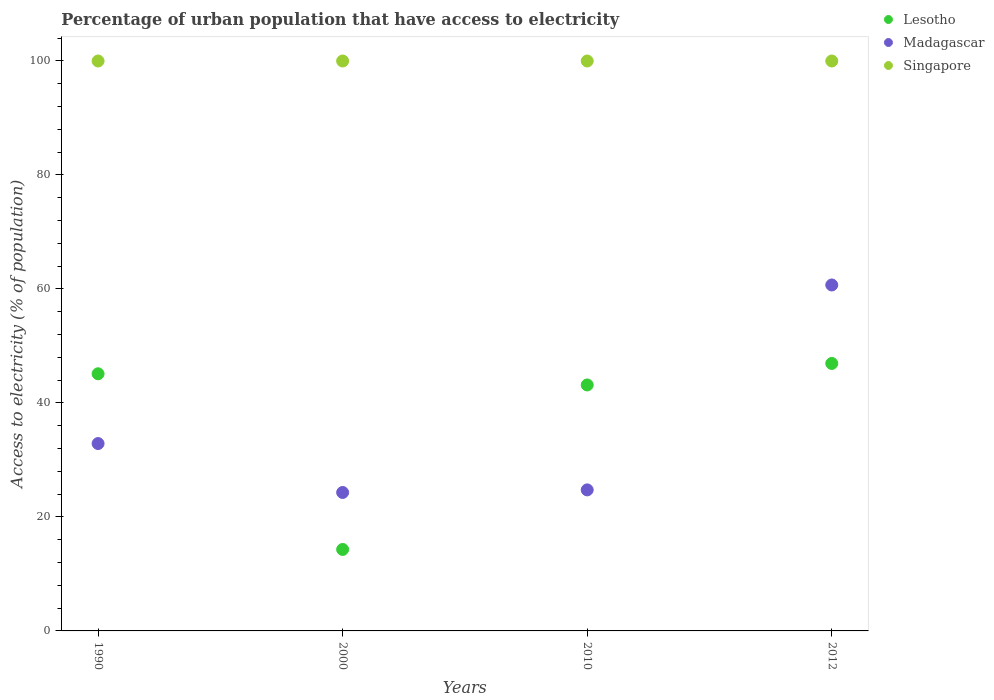How many different coloured dotlines are there?
Your response must be concise. 3. What is the percentage of urban population that have access to electricity in Lesotho in 1990?
Offer a terse response. 45.12. Across all years, what is the maximum percentage of urban population that have access to electricity in Lesotho?
Your answer should be compact. 46.93. Across all years, what is the minimum percentage of urban population that have access to electricity in Singapore?
Ensure brevity in your answer.  100. In which year was the percentage of urban population that have access to electricity in Madagascar maximum?
Give a very brief answer. 2012. In which year was the percentage of urban population that have access to electricity in Lesotho minimum?
Your response must be concise. 2000. What is the total percentage of urban population that have access to electricity in Singapore in the graph?
Provide a short and direct response. 400. What is the difference between the percentage of urban population that have access to electricity in Madagascar in 1990 and that in 2000?
Provide a short and direct response. 8.59. What is the difference between the percentage of urban population that have access to electricity in Singapore in 2010 and the percentage of urban population that have access to electricity in Madagascar in 2012?
Your answer should be compact. 39.3. What is the average percentage of urban population that have access to electricity in Lesotho per year?
Offer a very short reply. 37.38. In the year 2010, what is the difference between the percentage of urban population that have access to electricity in Singapore and percentage of urban population that have access to electricity in Madagascar?
Provide a succinct answer. 75.25. In how many years, is the percentage of urban population that have access to electricity in Lesotho greater than 52 %?
Give a very brief answer. 0. Is the percentage of urban population that have access to electricity in Lesotho in 2000 less than that in 2012?
Your answer should be compact. Yes. Is the difference between the percentage of urban population that have access to electricity in Singapore in 1990 and 2000 greater than the difference between the percentage of urban population that have access to electricity in Madagascar in 1990 and 2000?
Provide a succinct answer. No. What is the difference between the highest and the second highest percentage of urban population that have access to electricity in Lesotho?
Ensure brevity in your answer.  1.81. What is the difference between the highest and the lowest percentage of urban population that have access to electricity in Madagascar?
Give a very brief answer. 36.41. Does the percentage of urban population that have access to electricity in Madagascar monotonically increase over the years?
Your answer should be very brief. No. Does the graph contain any zero values?
Your response must be concise. No. Where does the legend appear in the graph?
Offer a very short reply. Top right. How are the legend labels stacked?
Make the answer very short. Vertical. What is the title of the graph?
Offer a terse response. Percentage of urban population that have access to electricity. What is the label or title of the X-axis?
Give a very brief answer. Years. What is the label or title of the Y-axis?
Give a very brief answer. Access to electricity (% of population). What is the Access to electricity (% of population) of Lesotho in 1990?
Make the answer very short. 45.12. What is the Access to electricity (% of population) in Madagascar in 1990?
Provide a short and direct response. 32.88. What is the Access to electricity (% of population) of Singapore in 1990?
Your answer should be very brief. 100. What is the Access to electricity (% of population) of Lesotho in 2000?
Offer a terse response. 14.29. What is the Access to electricity (% of population) in Madagascar in 2000?
Give a very brief answer. 24.29. What is the Access to electricity (% of population) in Lesotho in 2010?
Make the answer very short. 43.16. What is the Access to electricity (% of population) of Madagascar in 2010?
Your response must be concise. 24.75. What is the Access to electricity (% of population) in Singapore in 2010?
Offer a terse response. 100. What is the Access to electricity (% of population) in Lesotho in 2012?
Your answer should be compact. 46.93. What is the Access to electricity (% of population) in Madagascar in 2012?
Ensure brevity in your answer.  60.7. What is the Access to electricity (% of population) of Singapore in 2012?
Offer a very short reply. 100. Across all years, what is the maximum Access to electricity (% of population) in Lesotho?
Provide a short and direct response. 46.93. Across all years, what is the maximum Access to electricity (% of population) of Madagascar?
Provide a succinct answer. 60.7. Across all years, what is the maximum Access to electricity (% of population) of Singapore?
Offer a very short reply. 100. Across all years, what is the minimum Access to electricity (% of population) in Lesotho?
Offer a very short reply. 14.29. Across all years, what is the minimum Access to electricity (% of population) in Madagascar?
Keep it short and to the point. 24.29. What is the total Access to electricity (% of population) of Lesotho in the graph?
Keep it short and to the point. 149.5. What is the total Access to electricity (% of population) of Madagascar in the graph?
Ensure brevity in your answer.  142.61. What is the difference between the Access to electricity (% of population) in Lesotho in 1990 and that in 2000?
Give a very brief answer. 30.82. What is the difference between the Access to electricity (% of population) in Madagascar in 1990 and that in 2000?
Your answer should be compact. 8.59. What is the difference between the Access to electricity (% of population) in Singapore in 1990 and that in 2000?
Your answer should be very brief. 0. What is the difference between the Access to electricity (% of population) of Lesotho in 1990 and that in 2010?
Make the answer very short. 1.96. What is the difference between the Access to electricity (% of population) in Madagascar in 1990 and that in 2010?
Offer a terse response. 8.13. What is the difference between the Access to electricity (% of population) of Lesotho in 1990 and that in 2012?
Keep it short and to the point. -1.81. What is the difference between the Access to electricity (% of population) in Madagascar in 1990 and that in 2012?
Give a very brief answer. -27.82. What is the difference between the Access to electricity (% of population) of Lesotho in 2000 and that in 2010?
Your answer should be compact. -28.86. What is the difference between the Access to electricity (% of population) in Madagascar in 2000 and that in 2010?
Provide a succinct answer. -0.45. What is the difference between the Access to electricity (% of population) of Singapore in 2000 and that in 2010?
Keep it short and to the point. 0. What is the difference between the Access to electricity (% of population) in Lesotho in 2000 and that in 2012?
Your response must be concise. -32.64. What is the difference between the Access to electricity (% of population) in Madagascar in 2000 and that in 2012?
Provide a short and direct response. -36.41. What is the difference between the Access to electricity (% of population) in Singapore in 2000 and that in 2012?
Provide a short and direct response. 0. What is the difference between the Access to electricity (% of population) of Lesotho in 2010 and that in 2012?
Provide a short and direct response. -3.77. What is the difference between the Access to electricity (% of population) in Madagascar in 2010 and that in 2012?
Provide a short and direct response. -35.95. What is the difference between the Access to electricity (% of population) in Lesotho in 1990 and the Access to electricity (% of population) in Madagascar in 2000?
Provide a succinct answer. 20.83. What is the difference between the Access to electricity (% of population) in Lesotho in 1990 and the Access to electricity (% of population) in Singapore in 2000?
Your answer should be compact. -54.88. What is the difference between the Access to electricity (% of population) of Madagascar in 1990 and the Access to electricity (% of population) of Singapore in 2000?
Your answer should be very brief. -67.12. What is the difference between the Access to electricity (% of population) in Lesotho in 1990 and the Access to electricity (% of population) in Madagascar in 2010?
Make the answer very short. 20.37. What is the difference between the Access to electricity (% of population) of Lesotho in 1990 and the Access to electricity (% of population) of Singapore in 2010?
Keep it short and to the point. -54.88. What is the difference between the Access to electricity (% of population) in Madagascar in 1990 and the Access to electricity (% of population) in Singapore in 2010?
Give a very brief answer. -67.12. What is the difference between the Access to electricity (% of population) of Lesotho in 1990 and the Access to electricity (% of population) of Madagascar in 2012?
Make the answer very short. -15.58. What is the difference between the Access to electricity (% of population) in Lesotho in 1990 and the Access to electricity (% of population) in Singapore in 2012?
Your answer should be very brief. -54.88. What is the difference between the Access to electricity (% of population) of Madagascar in 1990 and the Access to electricity (% of population) of Singapore in 2012?
Ensure brevity in your answer.  -67.12. What is the difference between the Access to electricity (% of population) in Lesotho in 2000 and the Access to electricity (% of population) in Madagascar in 2010?
Provide a succinct answer. -10.45. What is the difference between the Access to electricity (% of population) of Lesotho in 2000 and the Access to electricity (% of population) of Singapore in 2010?
Ensure brevity in your answer.  -85.71. What is the difference between the Access to electricity (% of population) of Madagascar in 2000 and the Access to electricity (% of population) of Singapore in 2010?
Your answer should be compact. -75.71. What is the difference between the Access to electricity (% of population) of Lesotho in 2000 and the Access to electricity (% of population) of Madagascar in 2012?
Ensure brevity in your answer.  -46.41. What is the difference between the Access to electricity (% of population) in Lesotho in 2000 and the Access to electricity (% of population) in Singapore in 2012?
Offer a terse response. -85.71. What is the difference between the Access to electricity (% of population) of Madagascar in 2000 and the Access to electricity (% of population) of Singapore in 2012?
Your answer should be very brief. -75.71. What is the difference between the Access to electricity (% of population) of Lesotho in 2010 and the Access to electricity (% of population) of Madagascar in 2012?
Your answer should be very brief. -17.54. What is the difference between the Access to electricity (% of population) of Lesotho in 2010 and the Access to electricity (% of population) of Singapore in 2012?
Ensure brevity in your answer.  -56.84. What is the difference between the Access to electricity (% of population) in Madagascar in 2010 and the Access to electricity (% of population) in Singapore in 2012?
Give a very brief answer. -75.25. What is the average Access to electricity (% of population) of Lesotho per year?
Your answer should be compact. 37.38. What is the average Access to electricity (% of population) in Madagascar per year?
Your answer should be compact. 35.65. What is the average Access to electricity (% of population) in Singapore per year?
Provide a short and direct response. 100. In the year 1990, what is the difference between the Access to electricity (% of population) in Lesotho and Access to electricity (% of population) in Madagascar?
Your answer should be compact. 12.24. In the year 1990, what is the difference between the Access to electricity (% of population) of Lesotho and Access to electricity (% of population) of Singapore?
Provide a succinct answer. -54.88. In the year 1990, what is the difference between the Access to electricity (% of population) in Madagascar and Access to electricity (% of population) in Singapore?
Provide a succinct answer. -67.12. In the year 2000, what is the difference between the Access to electricity (% of population) in Lesotho and Access to electricity (% of population) in Madagascar?
Your response must be concise. -10. In the year 2000, what is the difference between the Access to electricity (% of population) in Lesotho and Access to electricity (% of population) in Singapore?
Provide a succinct answer. -85.71. In the year 2000, what is the difference between the Access to electricity (% of population) in Madagascar and Access to electricity (% of population) in Singapore?
Offer a very short reply. -75.71. In the year 2010, what is the difference between the Access to electricity (% of population) of Lesotho and Access to electricity (% of population) of Madagascar?
Your answer should be very brief. 18.41. In the year 2010, what is the difference between the Access to electricity (% of population) of Lesotho and Access to electricity (% of population) of Singapore?
Give a very brief answer. -56.84. In the year 2010, what is the difference between the Access to electricity (% of population) of Madagascar and Access to electricity (% of population) of Singapore?
Provide a succinct answer. -75.25. In the year 2012, what is the difference between the Access to electricity (% of population) of Lesotho and Access to electricity (% of population) of Madagascar?
Provide a succinct answer. -13.77. In the year 2012, what is the difference between the Access to electricity (% of population) of Lesotho and Access to electricity (% of population) of Singapore?
Offer a very short reply. -53.07. In the year 2012, what is the difference between the Access to electricity (% of population) of Madagascar and Access to electricity (% of population) of Singapore?
Your answer should be compact. -39.3. What is the ratio of the Access to electricity (% of population) in Lesotho in 1990 to that in 2000?
Your response must be concise. 3.16. What is the ratio of the Access to electricity (% of population) in Madagascar in 1990 to that in 2000?
Your answer should be very brief. 1.35. What is the ratio of the Access to electricity (% of population) of Lesotho in 1990 to that in 2010?
Give a very brief answer. 1.05. What is the ratio of the Access to electricity (% of population) in Madagascar in 1990 to that in 2010?
Provide a succinct answer. 1.33. What is the ratio of the Access to electricity (% of population) of Singapore in 1990 to that in 2010?
Ensure brevity in your answer.  1. What is the ratio of the Access to electricity (% of population) in Lesotho in 1990 to that in 2012?
Provide a short and direct response. 0.96. What is the ratio of the Access to electricity (% of population) in Madagascar in 1990 to that in 2012?
Give a very brief answer. 0.54. What is the ratio of the Access to electricity (% of population) of Singapore in 1990 to that in 2012?
Offer a terse response. 1. What is the ratio of the Access to electricity (% of population) of Lesotho in 2000 to that in 2010?
Your response must be concise. 0.33. What is the ratio of the Access to electricity (% of population) in Madagascar in 2000 to that in 2010?
Your answer should be compact. 0.98. What is the ratio of the Access to electricity (% of population) of Lesotho in 2000 to that in 2012?
Provide a short and direct response. 0.3. What is the ratio of the Access to electricity (% of population) in Madagascar in 2000 to that in 2012?
Give a very brief answer. 0.4. What is the ratio of the Access to electricity (% of population) in Singapore in 2000 to that in 2012?
Keep it short and to the point. 1. What is the ratio of the Access to electricity (% of population) of Lesotho in 2010 to that in 2012?
Your response must be concise. 0.92. What is the ratio of the Access to electricity (% of population) in Madagascar in 2010 to that in 2012?
Give a very brief answer. 0.41. What is the ratio of the Access to electricity (% of population) in Singapore in 2010 to that in 2012?
Offer a terse response. 1. What is the difference between the highest and the second highest Access to electricity (% of population) in Lesotho?
Ensure brevity in your answer.  1.81. What is the difference between the highest and the second highest Access to electricity (% of population) in Madagascar?
Offer a very short reply. 27.82. What is the difference between the highest and the lowest Access to electricity (% of population) in Lesotho?
Offer a terse response. 32.64. What is the difference between the highest and the lowest Access to electricity (% of population) of Madagascar?
Your answer should be compact. 36.41. What is the difference between the highest and the lowest Access to electricity (% of population) in Singapore?
Your answer should be very brief. 0. 